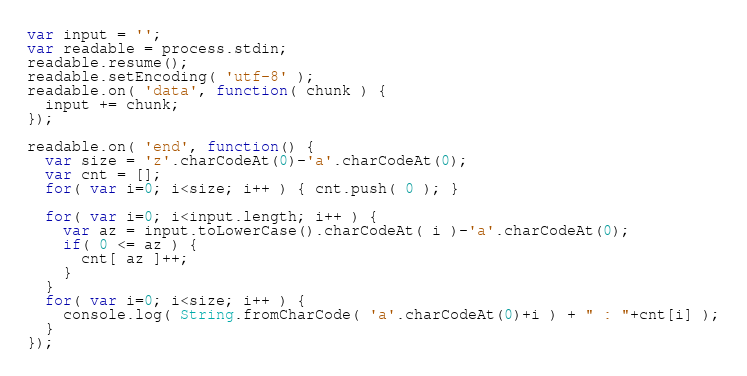<code> <loc_0><loc_0><loc_500><loc_500><_JavaScript_>var input = '';
var readable = process.stdin;
readable.resume();
readable.setEncoding( 'utf-8' );
readable.on( 'data', function( chunk ) {
  input += chunk;
});

readable.on( 'end', function() {
  var size = 'z'.charCodeAt(0)-'a'.charCodeAt(0);
  var cnt = [];
  for( var i=0; i<size; i++ ) { cnt.push( 0 ); }
  
  for( var i=0; i<input.length; i++ ) {
    var az = input.toLowerCase().charCodeAt( i )-'a'.charCodeAt(0);
    if( 0 <= az ) {
      cnt[ az ]++;
    }
  }
  for( var i=0; i<size; i++ ) {
    console.log( String.fromCharCode( 'a'.charCodeAt(0)+i ) + " : "+cnt[i] );
  }
});</code> 